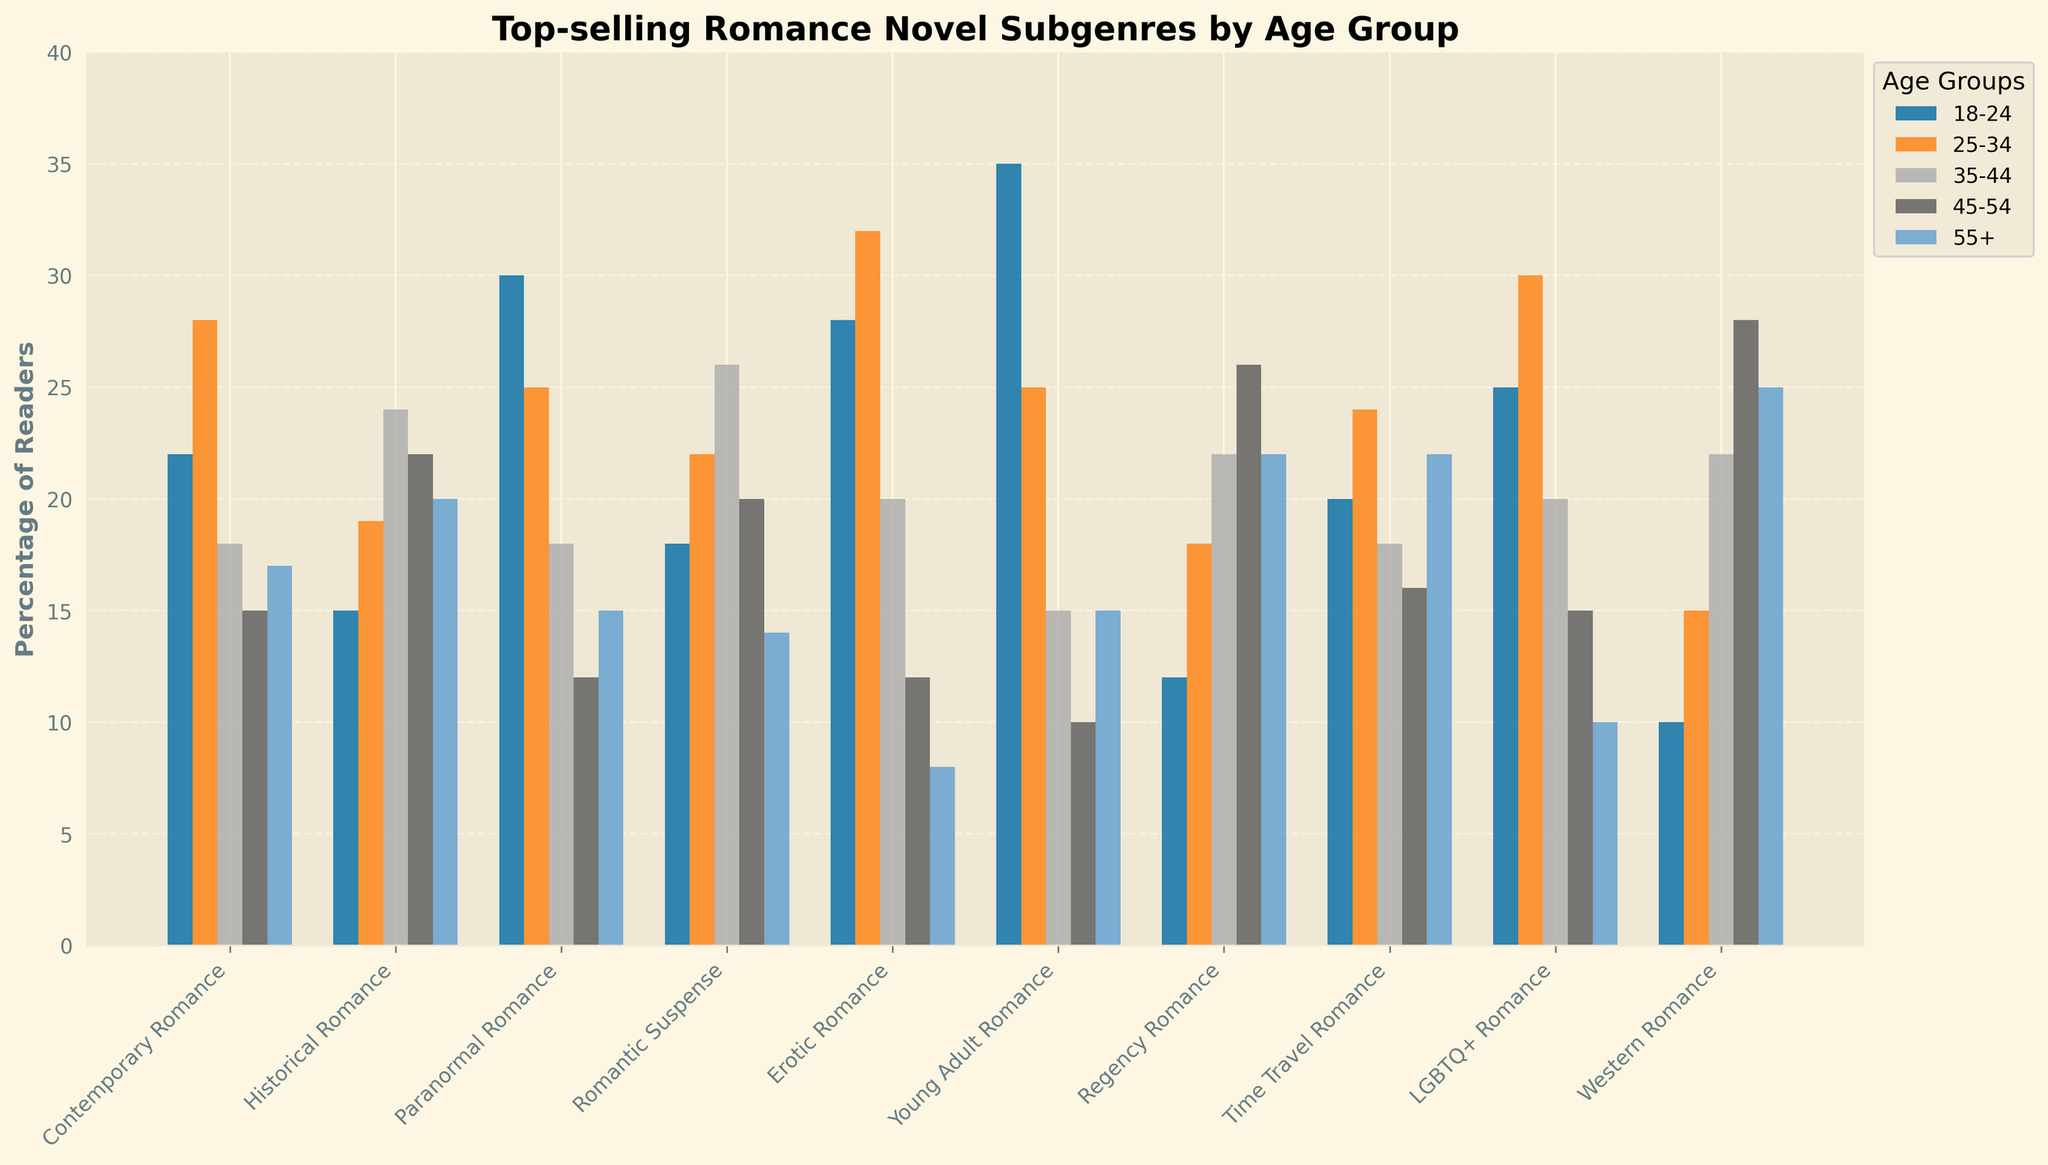Which subgenre is most popular among the 18-24 age group? The tallest bar in the 18-24 age group corresponds to the subgenre Young Adult Romance.
Answer: Young Adult Romance Which age group has the highest percentage of readers in Erotic Romance? The highest bar for Erotic Romance corresponds to the 25-34 age group.
Answer: 25-34 Compare the popularity of Historical Romance between the 18-24 and 55+ age groups. The bar for Historical Romance for the 18-24 age group is lower (15%) than for the 55+ age group (20%).
Answer: 55+ age group Which subgenre shows a decreasing trend in popularity as the age group increases? Erotic Romance shows a clear decreasing trend as the age group increases from the leftmost bar (18-24) to the rightmost bar (55+).
Answer: Erotic Romance What is the combined percentage of readers for Contemporary Romance in the 35-44 and 45-54 age groups? Add the heights of the bars for Contemporary Romance in the 35-44 (18%) and 45-54 (15%) age groups: 18% + 15% = 33%.
Answer: 33% Which age group has the lowest percentage of readers for Paranormal Romance? The shortest bar for Paranormal Romance corresponds to the 55+ age group (15%).
Answer: 55+ Compare the popularity of Regency Romance among the 18-24 and 45-54 age groups. The bar for Regency Romance for the 18-24 age group is much lower (12%) compared to the 45-54 age group (26%).
Answer: 45-54 Which subgenre is equally popular among the 18-24 and 25-34 age groups? Young Adult Romance has equal bar heights for the 18-24 and 25-34 age groups (both 35% and 25% respectively).
Answer: Young Adult Romance What is the average percentage of readers for Western Romance in the 45-54 and 55+ age groups? Add the percentage values for the 45-54 (28%) and 55+ (25%) age groups, then divide by 2: (28% + 25%) / 2 = 26.5%.
Answer: 26.5% Which age group has more readers in Time Travel Romance, 25-34 or 35-44? The bar for Time Travel Romance in the 25-34 age group is slightly taller (24%) compared to that in the 35-44 age group (18%).
Answer: 25-34 